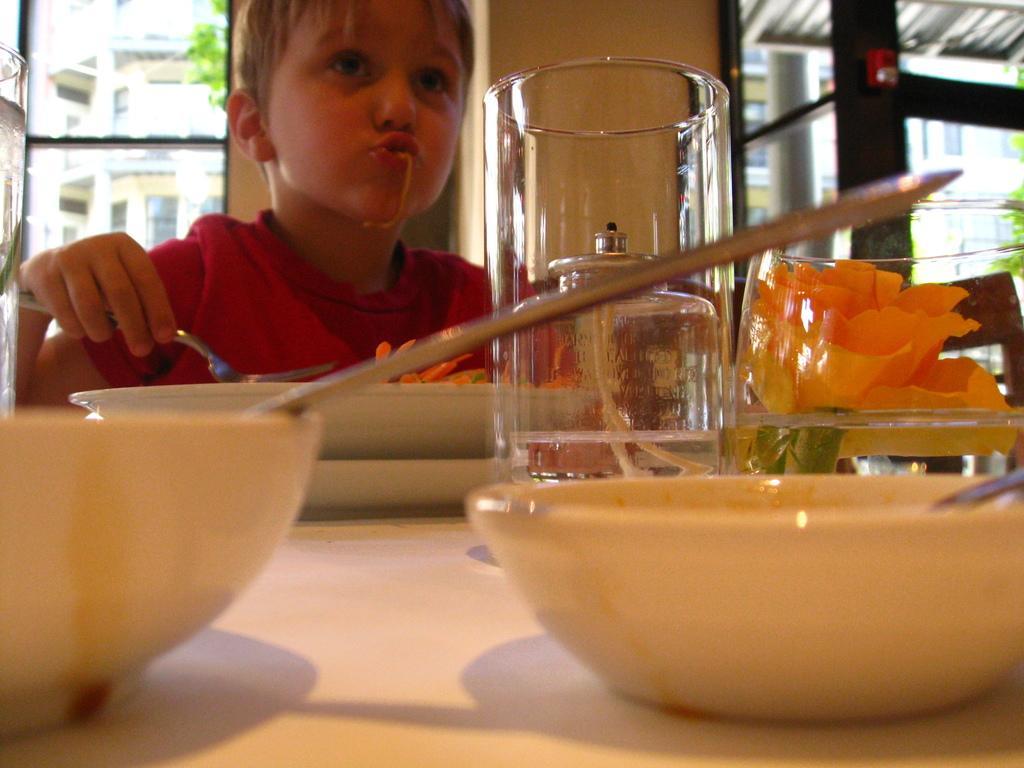Describe this image in one or two sentences. In this picture there is a table, on that table there are bowls, a kid sitting in front of the table and holding a spoon in his hand, in the background there is wall and a glass windows. 